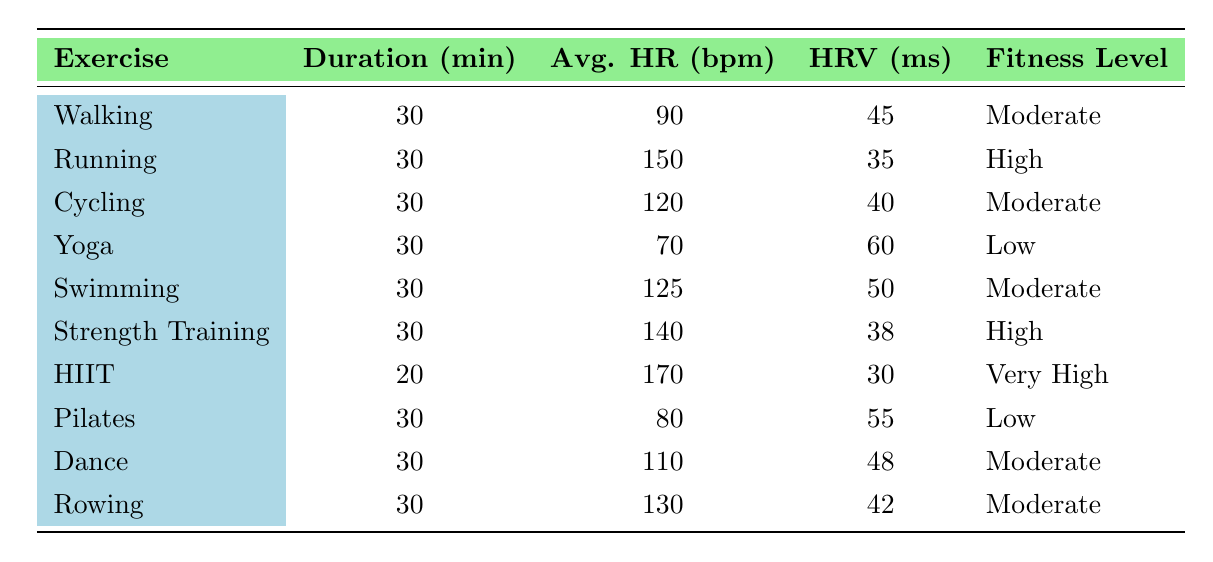What is the average heart rate during Yoga? The table shows that the average heart rate during Yoga is 70 beats per minute.
Answer: 70 bpm How many exercises have a fitness level of "Moderate"? The table lists five exercises with a fitness level of "Moderate": Walking, Cycling, Swimming, Dance, and Rowing.
Answer: 5 What is the difference in heart rate variability between Walking and Running? Walking has a heart rate variability of 45 ms and Running has 35 ms. The difference is 45 - 35 = 10 ms.
Answer: 10 ms Which exercise has the highest average heart rate, and what is that rate? The table indicates that HIIT has the highest average heart rate at 170 beats per minute.
Answer: HIIT, 170 bpm Which exercise has the lowest heart rate variability? HIIT has the lowest heart rate variability of 30 ms according to the table.
Answer: HIIT Is the average heart rate for Swimming higher than that for Cycling? Swimming has an average heart rate of 125 bpm and Cycling has 120 bpm. Since 125 is greater than 120, the statement is true.
Answer: Yes What is the total duration in minutes of all the exercises listed? Each exercise has a duration of 30 minutes except for HIIT, which has 20 minutes. Thus, total duration is (9 * 30) + 20 = 290 minutes.
Answer: 290 minutes How does the average heart rate of Strength Training compare to that of Pilates? The average heart rate for Strength Training is 140 bpm whereas for Pilates it is 80 bpm. Therefore, Strength Training is higher by 140 - 80 = 60 bpm.
Answer: 60 bpm Which exercise shows the greatest heart rate variability, and what is that value? The greatest heart rate variability is shown by Yoga, with a value of 60 ms as per the table.
Answer: Yoga, 60 ms Is the fitness level of Running lower than that of Strength Training? Both Running and Strength Training have a fitness level categorized as "High," so this statement is false.
Answer: No 